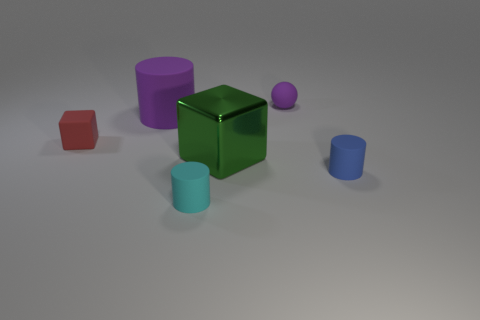Does the large shiny cube have the same color as the small sphere? no 